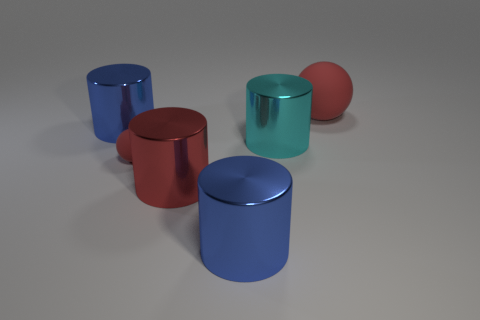Does the metal cylinder that is left of the tiny sphere have the same size as the red ball that is on the left side of the large matte sphere?
Your response must be concise. No. How many big cylinders are behind the tiny red rubber thing and right of the big red cylinder?
Offer a terse response. 1. Is the number of big red metal cylinders less than the number of large cylinders?
Ensure brevity in your answer.  Yes. There is a red cylinder; does it have the same size as the red rubber sphere that is on the left side of the big cyan cylinder?
Your answer should be very brief. No. What color is the metal object to the left of the red ball on the left side of the big red sphere?
Give a very brief answer. Blue. How many objects are either red balls on the left side of the big red ball or rubber things right of the large red cylinder?
Your answer should be very brief. 2. There is a big red object in front of the big ball; is its shape the same as the large blue object that is to the right of the small red matte sphere?
Provide a succinct answer. Yes. What material is the red thing to the right of the large blue metallic object that is in front of the blue shiny thing that is to the left of the small matte sphere made of?
Your answer should be compact. Rubber. What number of other objects are there of the same color as the big matte ball?
Ensure brevity in your answer.  2. How many purple objects are either large matte things or tiny matte spheres?
Your answer should be compact. 0. 